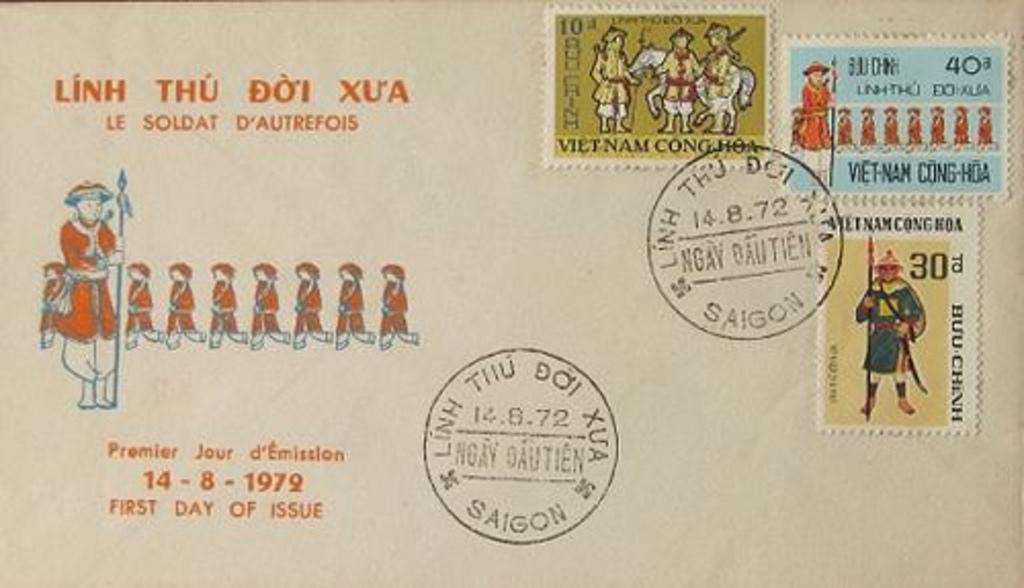What is the value for the stamp on the top right?
Your answer should be compact. 40. Where was this letter mailed from?
Provide a succinct answer. Saigon. 